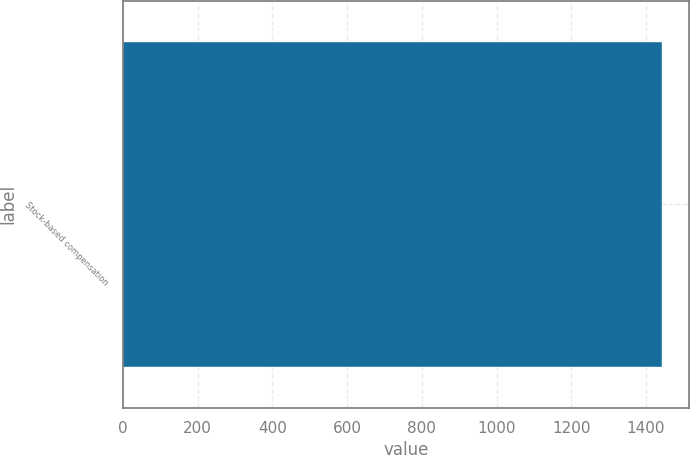<chart> <loc_0><loc_0><loc_500><loc_500><bar_chart><fcel>Stock-based compensation<nl><fcel>1443<nl></chart> 